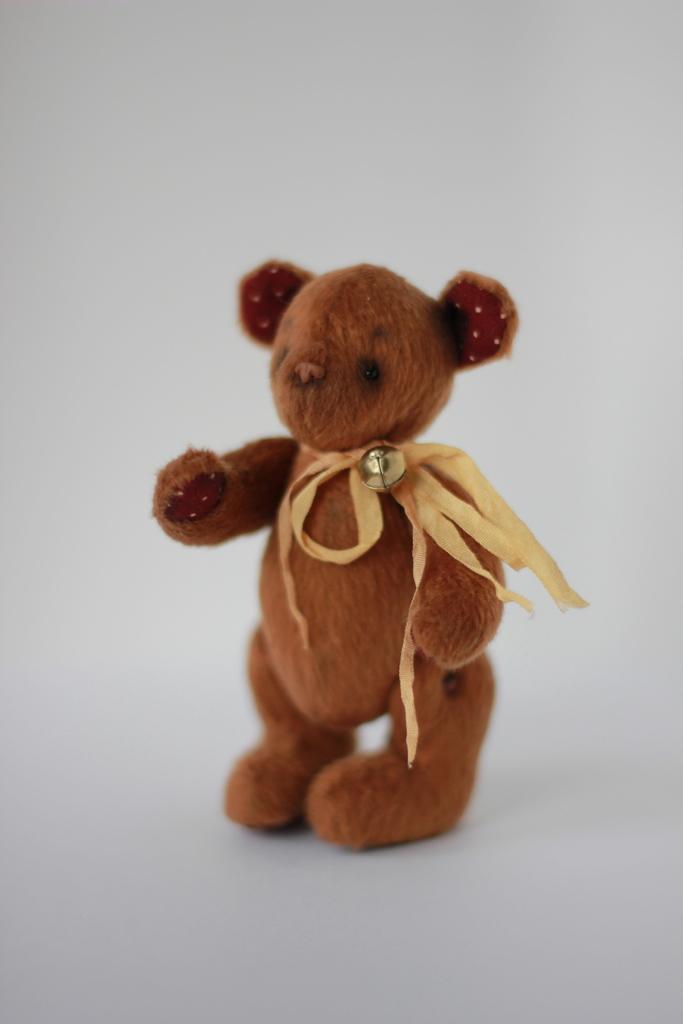How would you summarize this image in a sentence or two? Here we can see a brown teddy. Background it is in white color.  